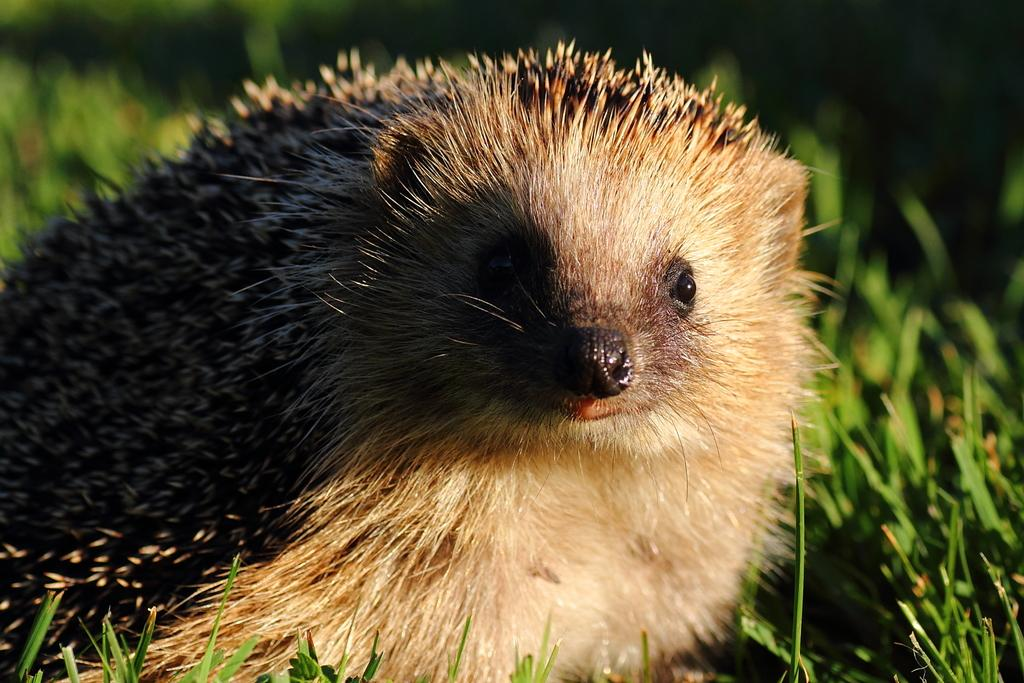What type of animal is in the picture? There is an animal in the picture, and it has thorns. Can you describe the animal's appearance? The animal has thorns, which suggests it might be a type of cactus or a similar plant with thorns. What can be seen in the background of the image? There are plants visible in the background of the image. What type of bell can be seen hanging from the animal's neck in the image? There is no bell present in the image; the animal has thorns instead. 